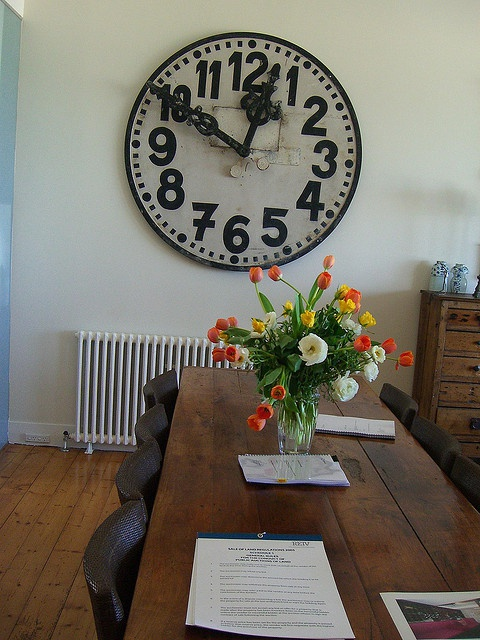Describe the objects in this image and their specific colors. I can see dining table in gray, maroon, darkgray, and black tones, clock in gray, darkgray, and black tones, book in gray, darkgray, black, and navy tones, chair in gray, black, and maroon tones, and chair in gray and black tones in this image. 